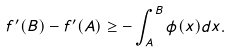Convert formula to latex. <formula><loc_0><loc_0><loc_500><loc_500>f ^ { \prime } ( B ) - f ^ { \prime } ( A ) \geq - \int _ { A } ^ { B } \phi ( x ) d x .</formula> 